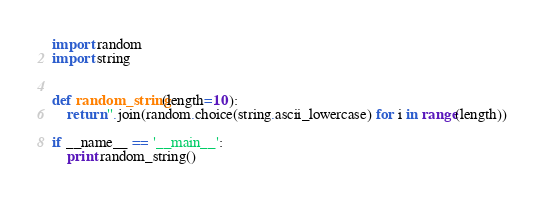<code> <loc_0><loc_0><loc_500><loc_500><_Python_>import random
import string


def random_string(length=10):
    return ''.join(random.choice(string.ascii_lowercase) for i in range(length))

if __name__ == '__main__':
    print random_string()
</code> 